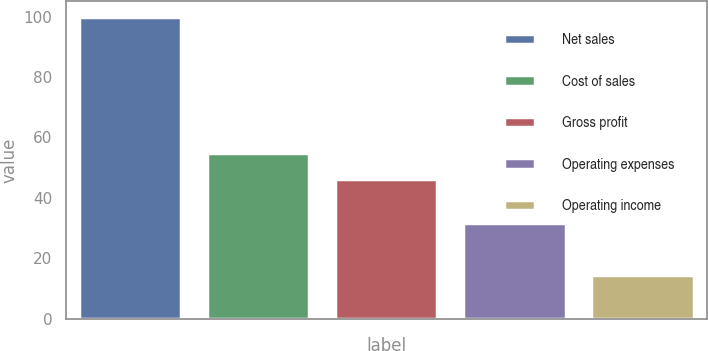Convert chart to OTSL. <chart><loc_0><loc_0><loc_500><loc_500><bar_chart><fcel>Net sales<fcel>Cost of sales<fcel>Gross profit<fcel>Operating expenses<fcel>Operating income<nl><fcel>100<fcel>54.75<fcel>46.2<fcel>31.7<fcel>14.5<nl></chart> 